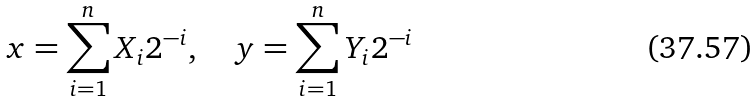Convert formula to latex. <formula><loc_0><loc_0><loc_500><loc_500>x = \sum _ { i = 1 } ^ { n } X _ { i } 2 ^ { - i } , \quad y = \sum _ { i = 1 } ^ { n } Y _ { i } 2 ^ { - i }</formula> 